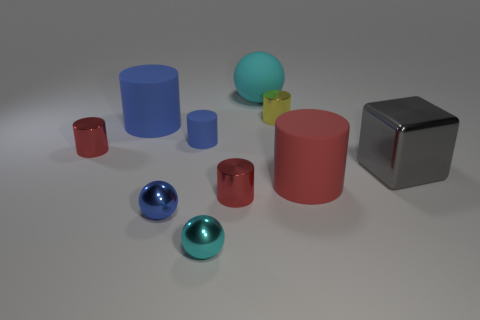What size is the cyan thing that is made of the same material as the large red cylinder?
Your response must be concise. Large. How many things are big blue matte objects or yellow matte things?
Ensure brevity in your answer.  1. There is a big matte object that is behind the big blue cylinder; what is its color?
Your answer should be compact. Cyan. What size is the other blue object that is the same shape as the large blue object?
Offer a very short reply. Small. How many things are either small red cylinders that are right of the small cyan metallic sphere or rubber things that are right of the tiny blue sphere?
Your answer should be compact. 4. There is a thing that is behind the large blue cylinder and in front of the large cyan sphere; how big is it?
Offer a terse response. Small. There is a yellow thing; is its shape the same as the small red shiny thing in front of the big red thing?
Your answer should be very brief. Yes. How many things are either metal objects that are on the left side of the cyan rubber object or large metal objects?
Offer a terse response. 5. Do the yellow cylinder and the red cylinder that is behind the gray metallic thing have the same material?
Provide a short and direct response. Yes. The tiny thing to the right of the big cyan ball that is on the left side of the red rubber cylinder is what shape?
Ensure brevity in your answer.  Cylinder. 